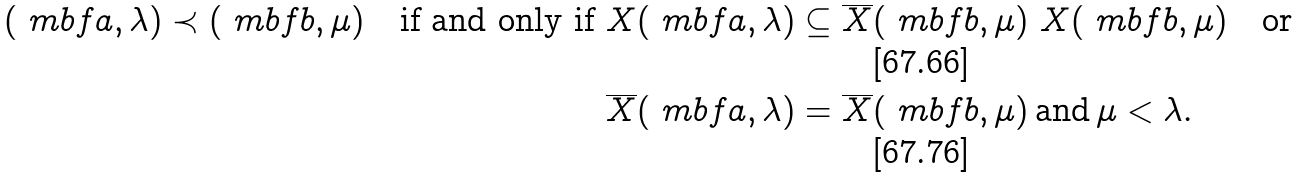Convert formula to latex. <formula><loc_0><loc_0><loc_500><loc_500>( \ m b f a , \lambda ) \prec ( \ m b f b , \mu ) \quad \text {if and only if } & X ( \ m b f a , \lambda ) \subseteq \overline { X } ( \ m b f b , \mu ) \ X ( \ m b f b , \mu ) \quad \text {or} \\ & \overline { X } ( \ m b f a , \lambda ) = \overline { X } ( \ m b f b , \mu ) \, \text {and} \, \mu < \lambda .</formula> 